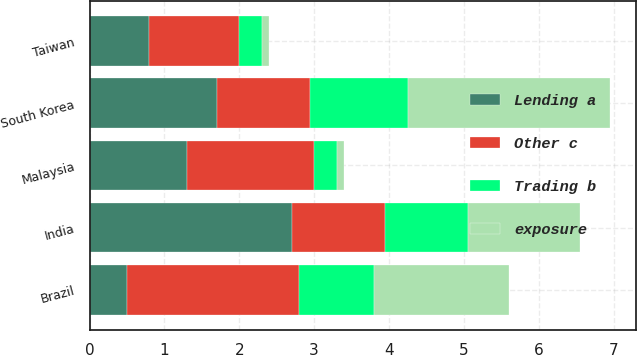Convert chart. <chart><loc_0><loc_0><loc_500><loc_500><stacked_bar_chart><ecel><fcel>South Korea<fcel>India<fcel>Brazil<fcel>Taiwan<fcel>Malaysia<nl><fcel>exposure<fcel>2.7<fcel>1.5<fcel>1.8<fcel>0.1<fcel>0.1<nl><fcel>Lending a<fcel>1.7<fcel>2.7<fcel>0.5<fcel>0.8<fcel>1.3<nl><fcel>Trading b<fcel>1.3<fcel>1.1<fcel>1<fcel>0.3<fcel>0.3<nl><fcel>Other c<fcel>1.25<fcel>1.25<fcel>2.3<fcel>1.2<fcel>1.7<nl></chart> 